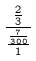Convert formula to latex. <formula><loc_0><loc_0><loc_500><loc_500>\frac { \frac { 2 } { 3 } } { \frac { \frac { 7 } { 3 0 0 } } { 1 } }</formula> 